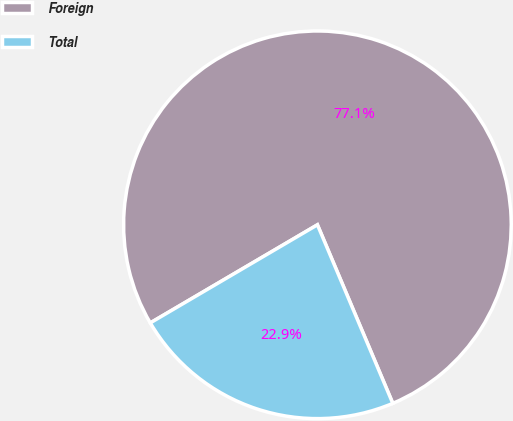Convert chart to OTSL. <chart><loc_0><loc_0><loc_500><loc_500><pie_chart><fcel>Foreign<fcel>Total<nl><fcel>77.09%<fcel>22.91%<nl></chart> 